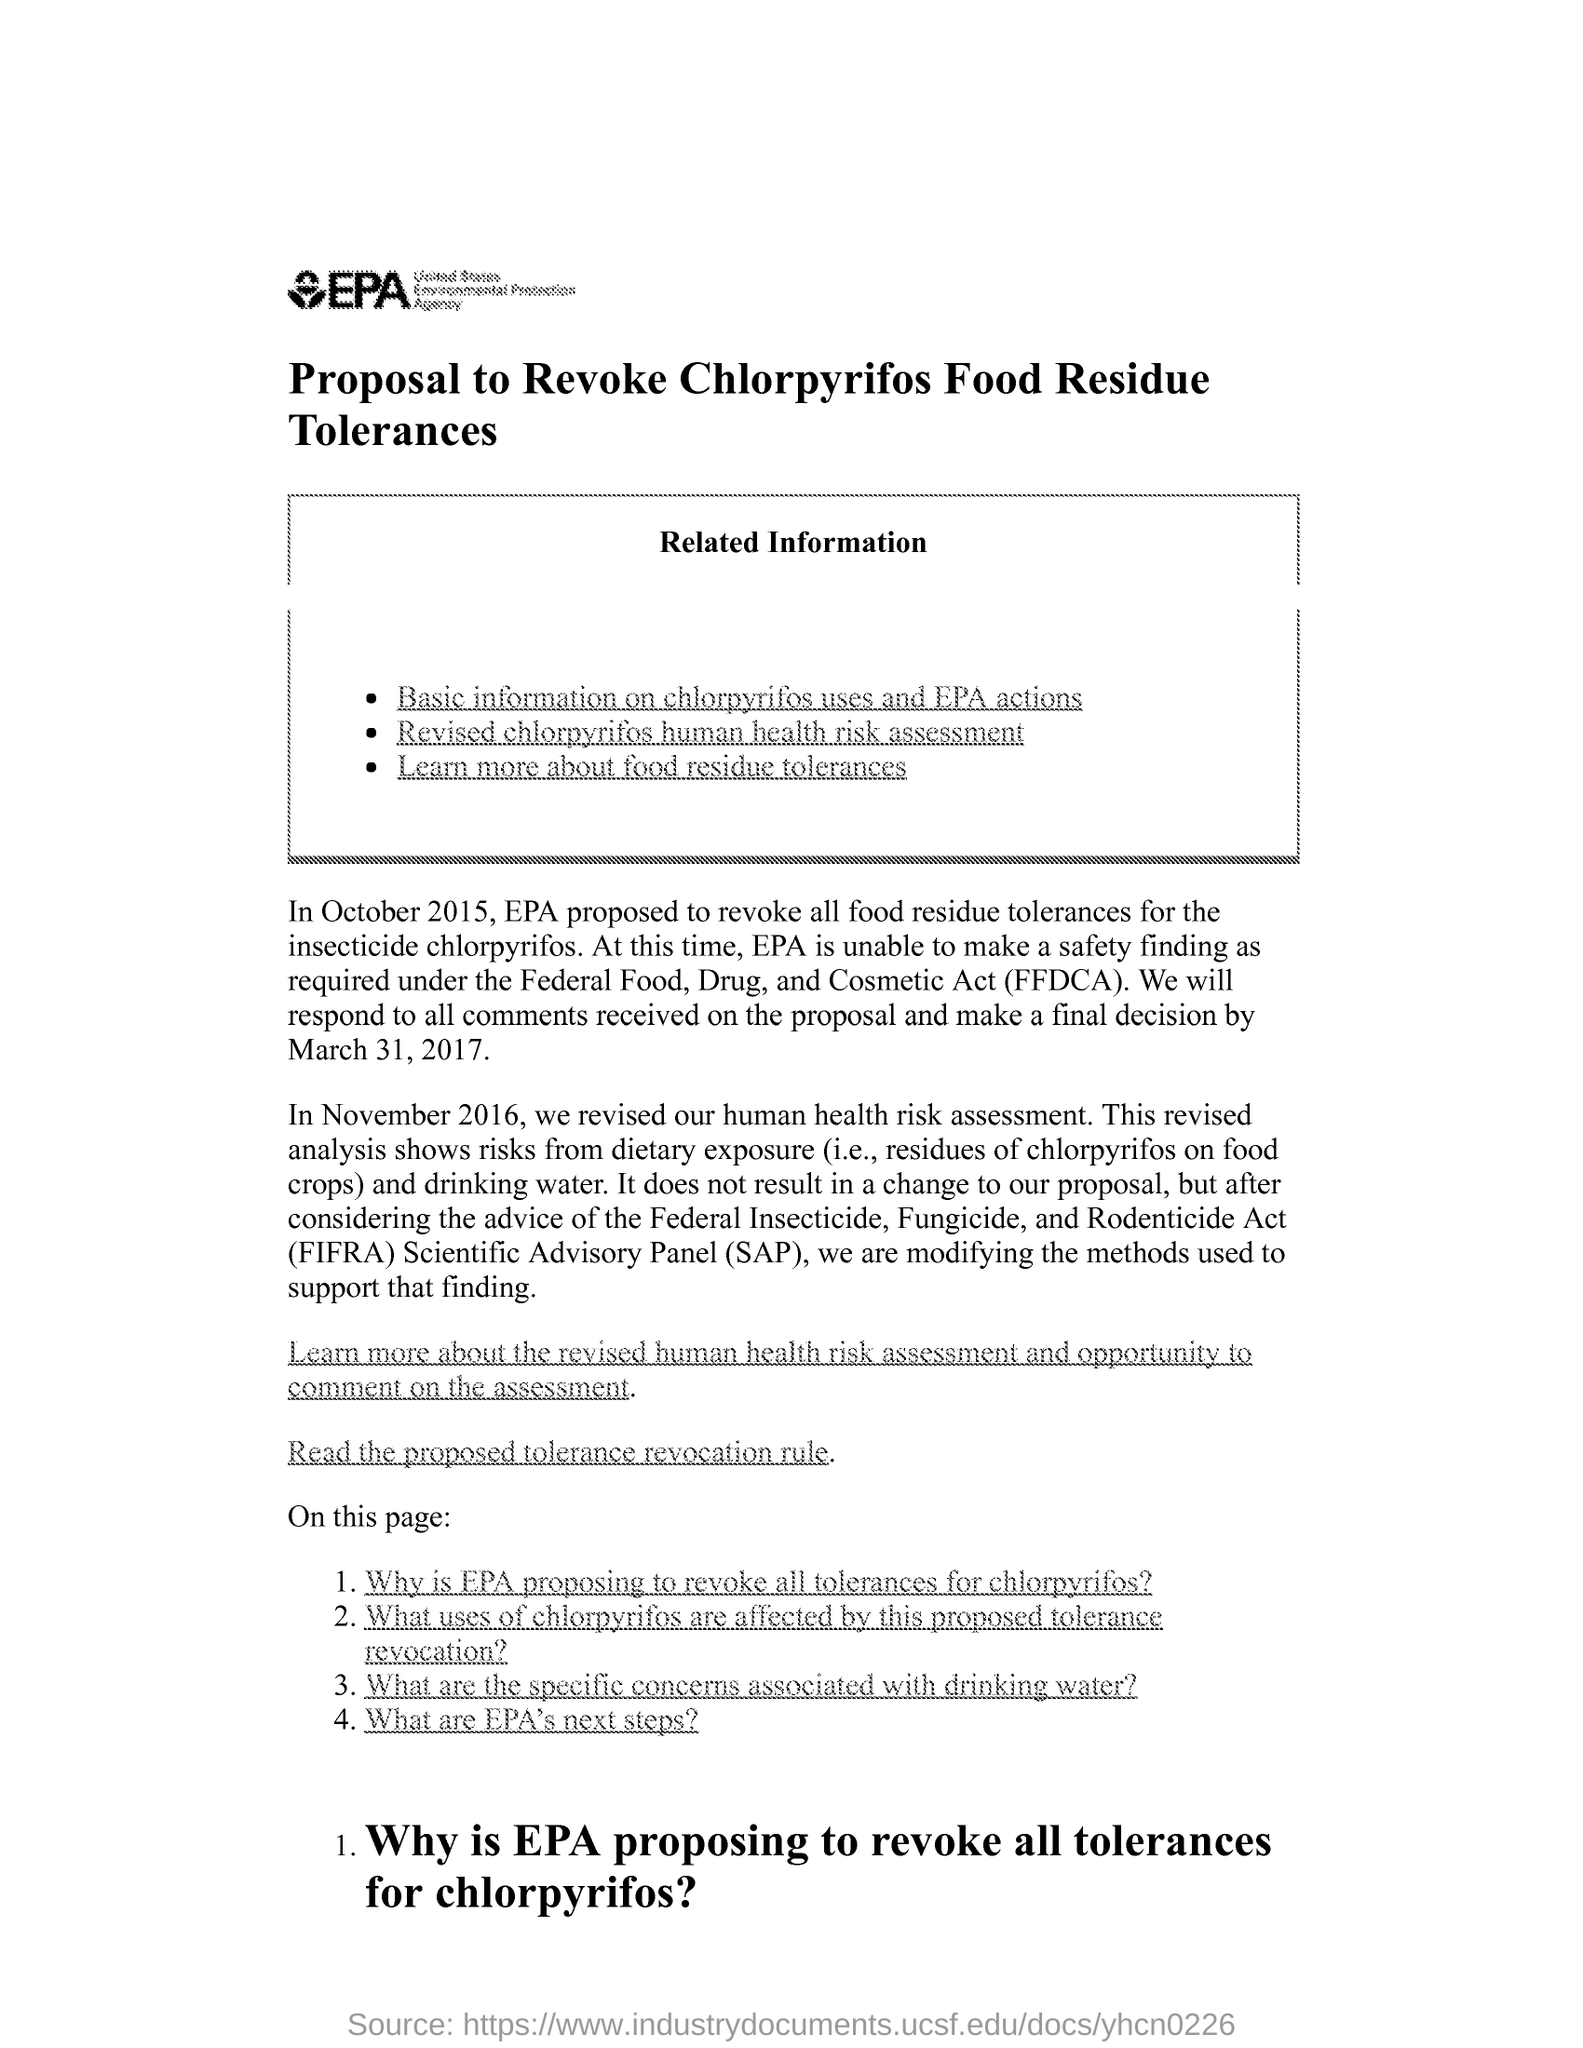Specify some key components in this picture. The title written inside the box is [insert title]. Related information can be found [insert information about where to find related information]. 